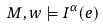Convert formula to latex. <formula><loc_0><loc_0><loc_500><loc_500>M , w \models I ^ { \alpha } ( e )</formula> 